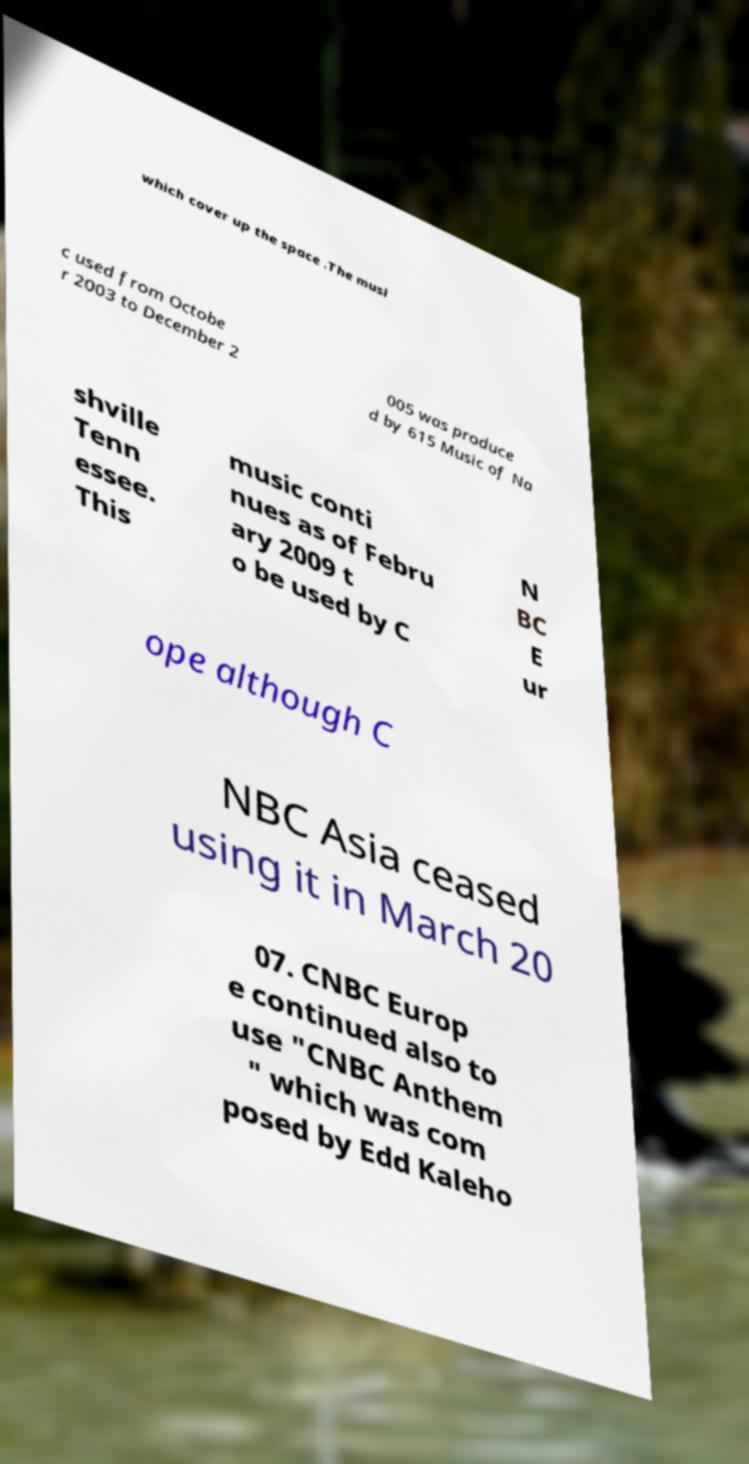Please identify and transcribe the text found in this image. which cover up the space .The musi c used from Octobe r 2003 to December 2 005 was produce d by 615 Music of Na shville Tenn essee. This music conti nues as of Febru ary 2009 t o be used by C N BC E ur ope although C NBC Asia ceased using it in March 20 07. CNBC Europ e continued also to use "CNBC Anthem " which was com posed by Edd Kaleho 